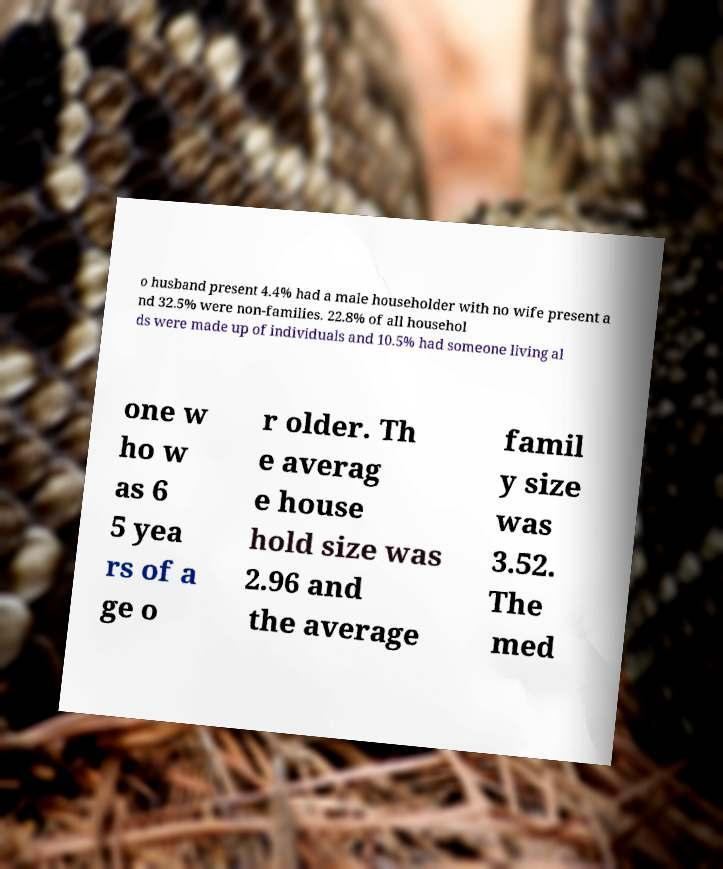Can you accurately transcribe the text from the provided image for me? o husband present 4.4% had a male householder with no wife present a nd 32.5% were non-families. 22.8% of all househol ds were made up of individuals and 10.5% had someone living al one w ho w as 6 5 yea rs of a ge o r older. Th e averag e house hold size was 2.96 and the average famil y size was 3.52. The med 